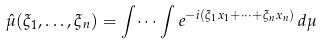Convert formula to latex. <formula><loc_0><loc_0><loc_500><loc_500>\hat { \mu } ( \xi _ { 1 } , \dots , \xi _ { n } ) = \int \dots \int e ^ { - i ( \xi _ { 1 } x _ { 1 } + \dots + \xi _ { n } x _ { n } ) } \, d \mu</formula> 